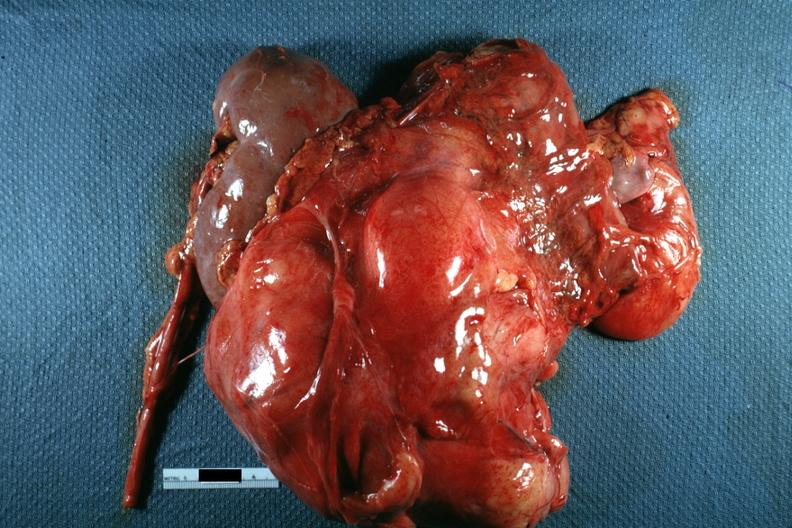what is present?
Answer the question using a single word or phrase. Retroperitoneal liposarcoma 